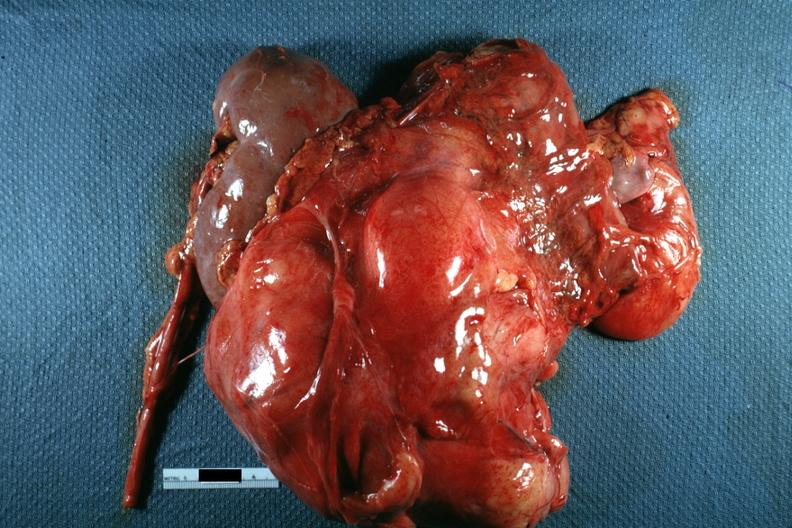what is present?
Answer the question using a single word or phrase. Retroperitoneal liposarcoma 